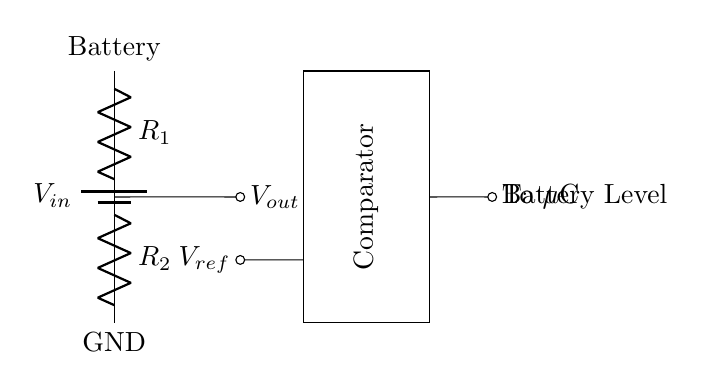What does V_in represent in this circuit? V_in is the input voltage provided by the battery, which supplies power to the voltage divider circuit.
Answer: Input voltage What are R_1 and R_2 in the circuit? R_1 and R_2 are the resistors in the voltage divider. They are used to divide the input voltage to a lower output voltage V_out.
Answer: Resistors What is the function of the comparator? The comparator is used to compare the output voltage V_out with a reference voltage V_ref to determine if the battery level is above or below a certain threshold.
Answer: To compare voltages How is V_out calculated in this voltage divider? V_out is calculated using the formula V_out = V_in * (R_2 / (R_1 + R_2)), where R_1 and R_2 are the resistances and V_in is the supply voltage from the battery.
Answer: By resistor values What signal is sent to the microcontroller? The output voltage V_out is sent to the microcontroller for processing to indicate the battery level.
Answer: V_out What does GND represent in this circuit? GND represents the ground reference point in the circuit, which is the lowest potential in the circuit and serves as a return path for current.
Answer: Ground 